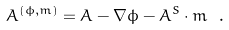<formula> <loc_0><loc_0><loc_500><loc_500>A ^ { ( \phi , m ) } = A - \nabla \phi - A ^ { S } \cdot m \ .</formula> 